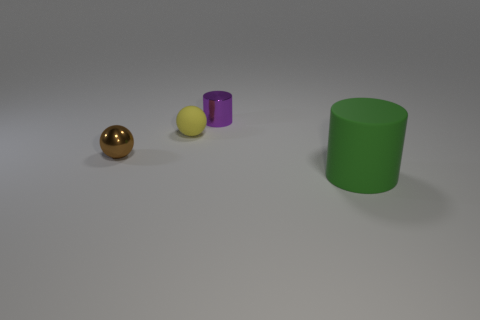What number of metallic objects are gray things or brown balls?
Your answer should be very brief. 1. What shape is the thing that is the same material as the yellow sphere?
Your answer should be compact. Cylinder. How many objects are on the right side of the brown ball and on the left side of the large green cylinder?
Provide a short and direct response. 2. What is the size of the thing on the right side of the purple cylinder?
Ensure brevity in your answer.  Large. What number of other objects are the same color as the small rubber thing?
Offer a terse response. 0. What material is the small thing that is left of the matte thing that is left of the small purple cylinder?
Offer a terse response. Metal. There is a cylinder to the left of the big green rubber cylinder; is it the same color as the tiny metal ball?
Make the answer very short. No. Is there any other thing that is the same material as the tiny purple object?
Provide a short and direct response. Yes. What number of other objects have the same shape as the big object?
Offer a terse response. 1. There is a yellow ball that is the same material as the large green cylinder; what is its size?
Your answer should be compact. Small. 